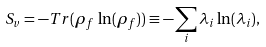Convert formula to latex. <formula><loc_0><loc_0><loc_500><loc_500>S _ { v } = - T r ( \rho _ { f } \, \ln ( \rho _ { f } ) ) \equiv - \sum _ { i } \lambda _ { i } \ln ( \lambda _ { i } ) ,</formula> 